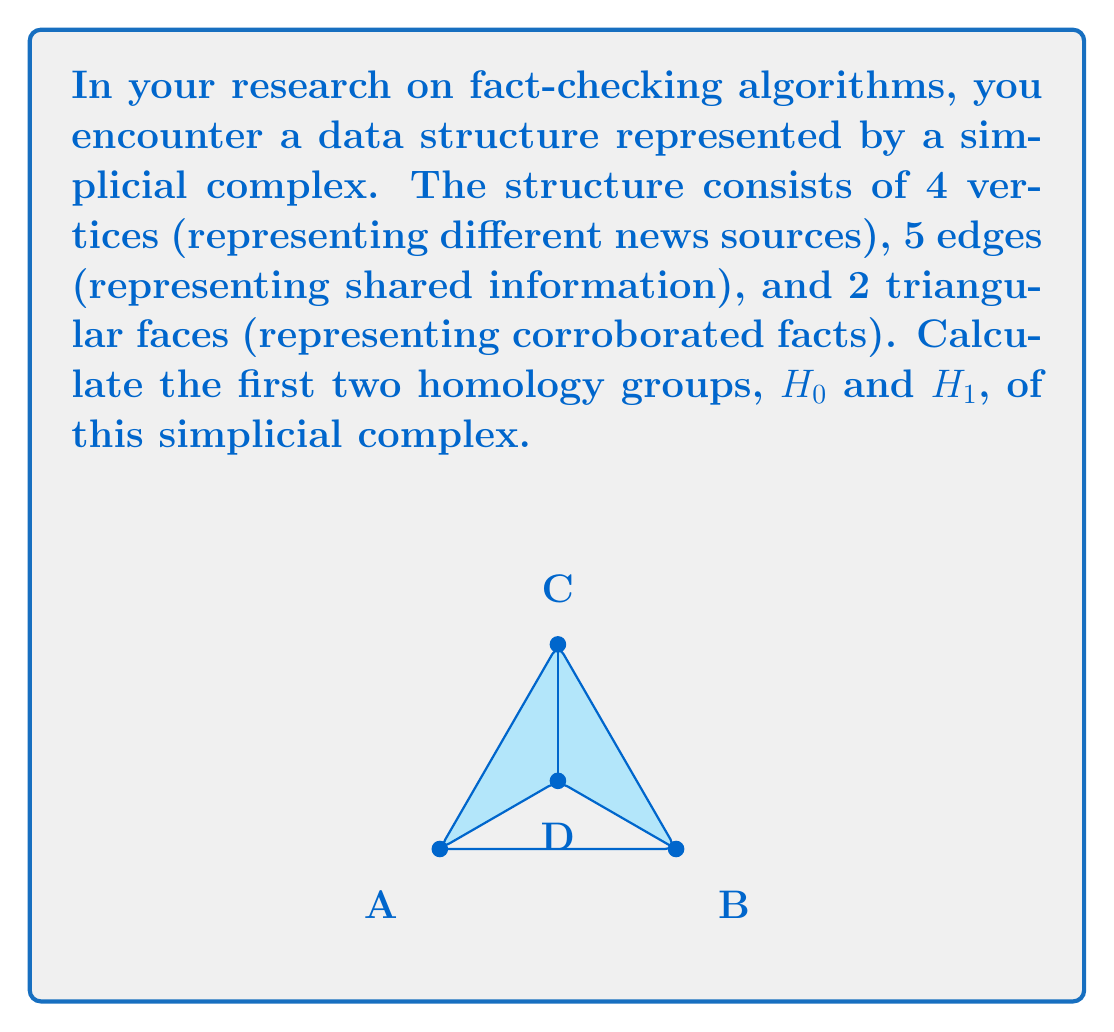Help me with this question. To calculate the homology groups, we'll follow these steps:

1) First, let's count the simplices in each dimension:
   $n_0 = 4$ (vertices)
   $n_1 = 5$ (edges)
   $n_2 = 2$ (triangular faces)

2) Now, we need to calculate the Betti numbers. For this, we'll use the formula:
   $$\beta_k = \text{rank}(Z_k) - \text{rank}(B_k)$$
   where $Z_k$ is the cycle group and $B_k$ is the boundary group.

3) For $H_0$:
   - $\beta_0$ is the number of connected components.
   - Our complex is connected, so $\beta_0 = 1$.

4) For $H_1$:
   - We need to calculate $\beta_1 = \text{rank}(Z_1) - \text{rank}(B_1)$.
   - $\text{rank}(Z_1) = n_1 - \text{rank}(\partial_1) = 5 - 3 = 2$
     (There are 5 edges, and the rank of the boundary map is 3 since the complex is connected)
   - $\text{rank}(B_1) = \text{rank}(\partial_2) = 2$
     (The boundary of each triangle is linearly independent)
   - Therefore, $\beta_1 = 2 - 2 = 0$

5) The homology groups are:
   $H_0 \cong \mathbb{Z}^{\beta_0} \cong \mathbb{Z}$
   $H_1 \cong \mathbb{Z}^{\beta_1} \cong 0$
Answer: $H_0 \cong \mathbb{Z}$, $H_1 \cong 0$ 